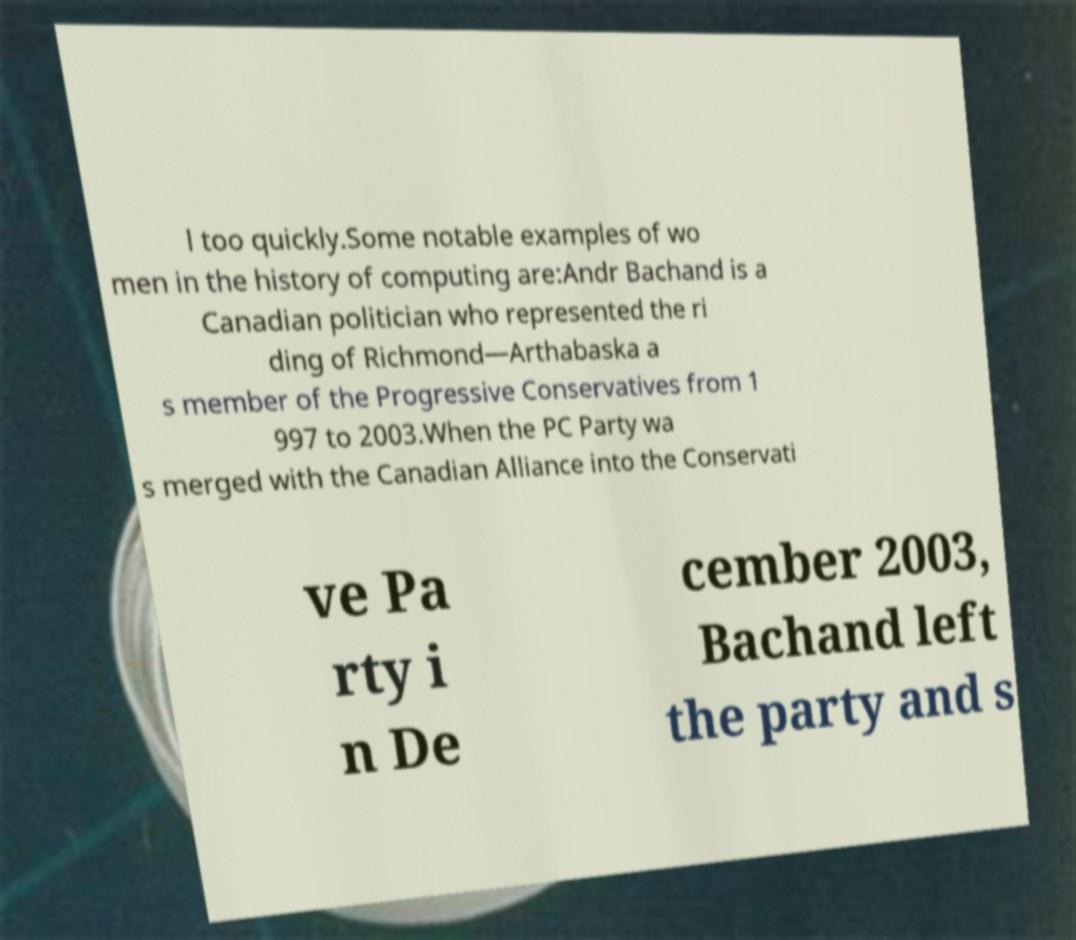Can you accurately transcribe the text from the provided image for me? l too quickly.Some notable examples of wo men in the history of computing are:Andr Bachand is a Canadian politician who represented the ri ding of Richmond—Arthabaska a s member of the Progressive Conservatives from 1 997 to 2003.When the PC Party wa s merged with the Canadian Alliance into the Conservati ve Pa rty i n De cember 2003, Bachand left the party and s 